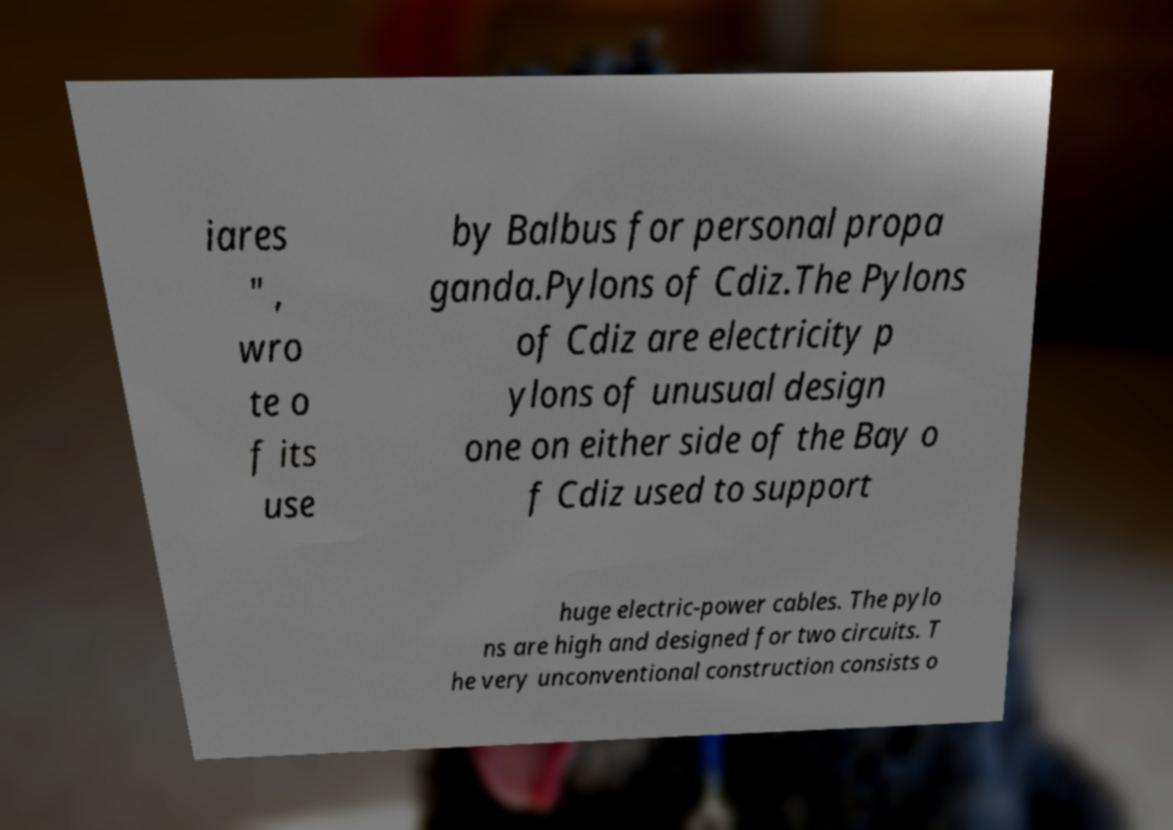I need the written content from this picture converted into text. Can you do that? iares " , wro te o f its use by Balbus for personal propa ganda.Pylons of Cdiz.The Pylons of Cdiz are electricity p ylons of unusual design one on either side of the Bay o f Cdiz used to support huge electric-power cables. The pylo ns are high and designed for two circuits. T he very unconventional construction consists o 